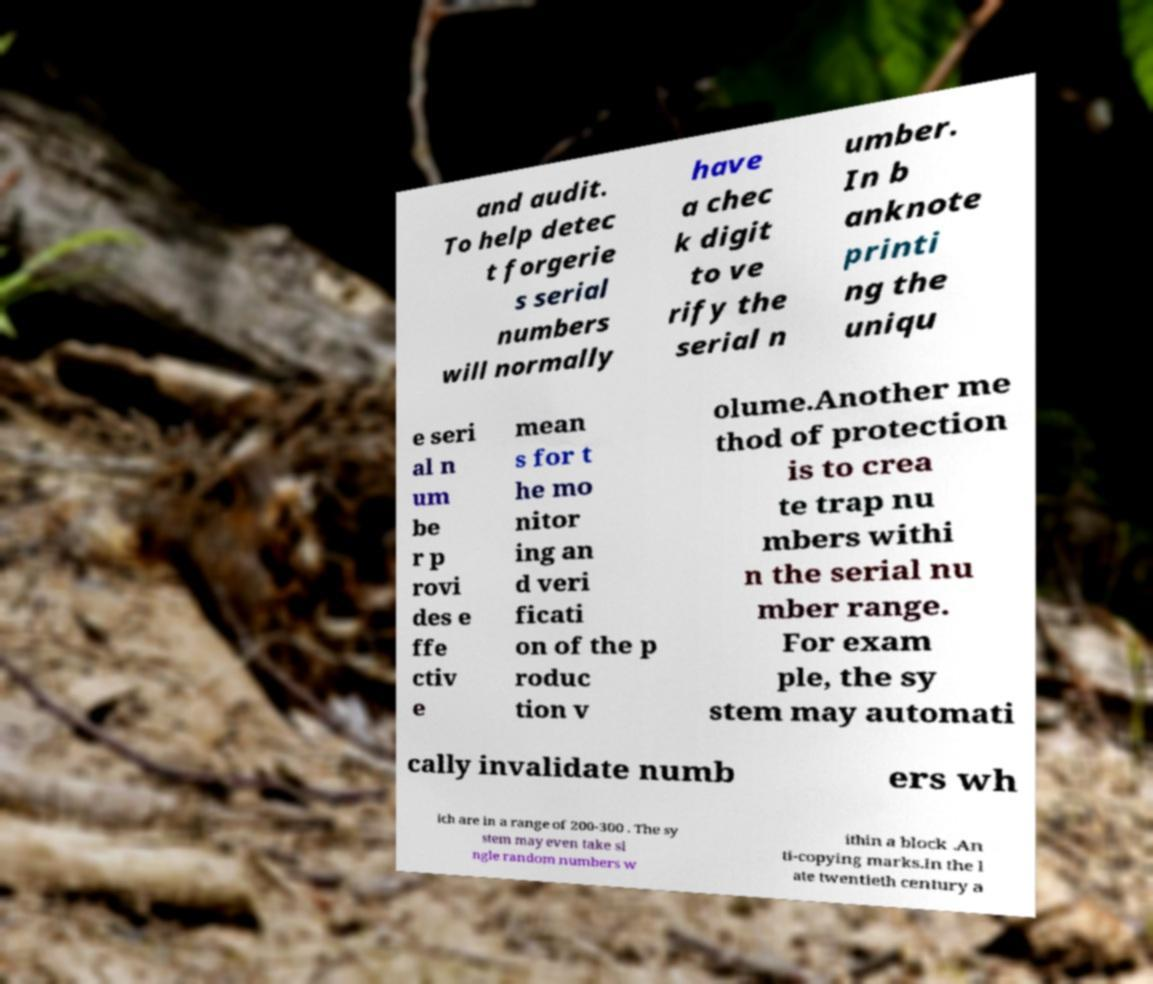For documentation purposes, I need the text within this image transcribed. Could you provide that? and audit. To help detec t forgerie s serial numbers will normally have a chec k digit to ve rify the serial n umber. In b anknote printi ng the uniqu e seri al n um be r p rovi des e ffe ctiv e mean s for t he mo nitor ing an d veri ficati on of the p roduc tion v olume.Another me thod of protection is to crea te trap nu mbers withi n the serial nu mber range. For exam ple, the sy stem may automati cally invalidate numb ers wh ich are in a range of 200-300 . The sy stem may even take si ngle random numbers w ithin a block .An ti-copying marks.In the l ate twentieth century a 